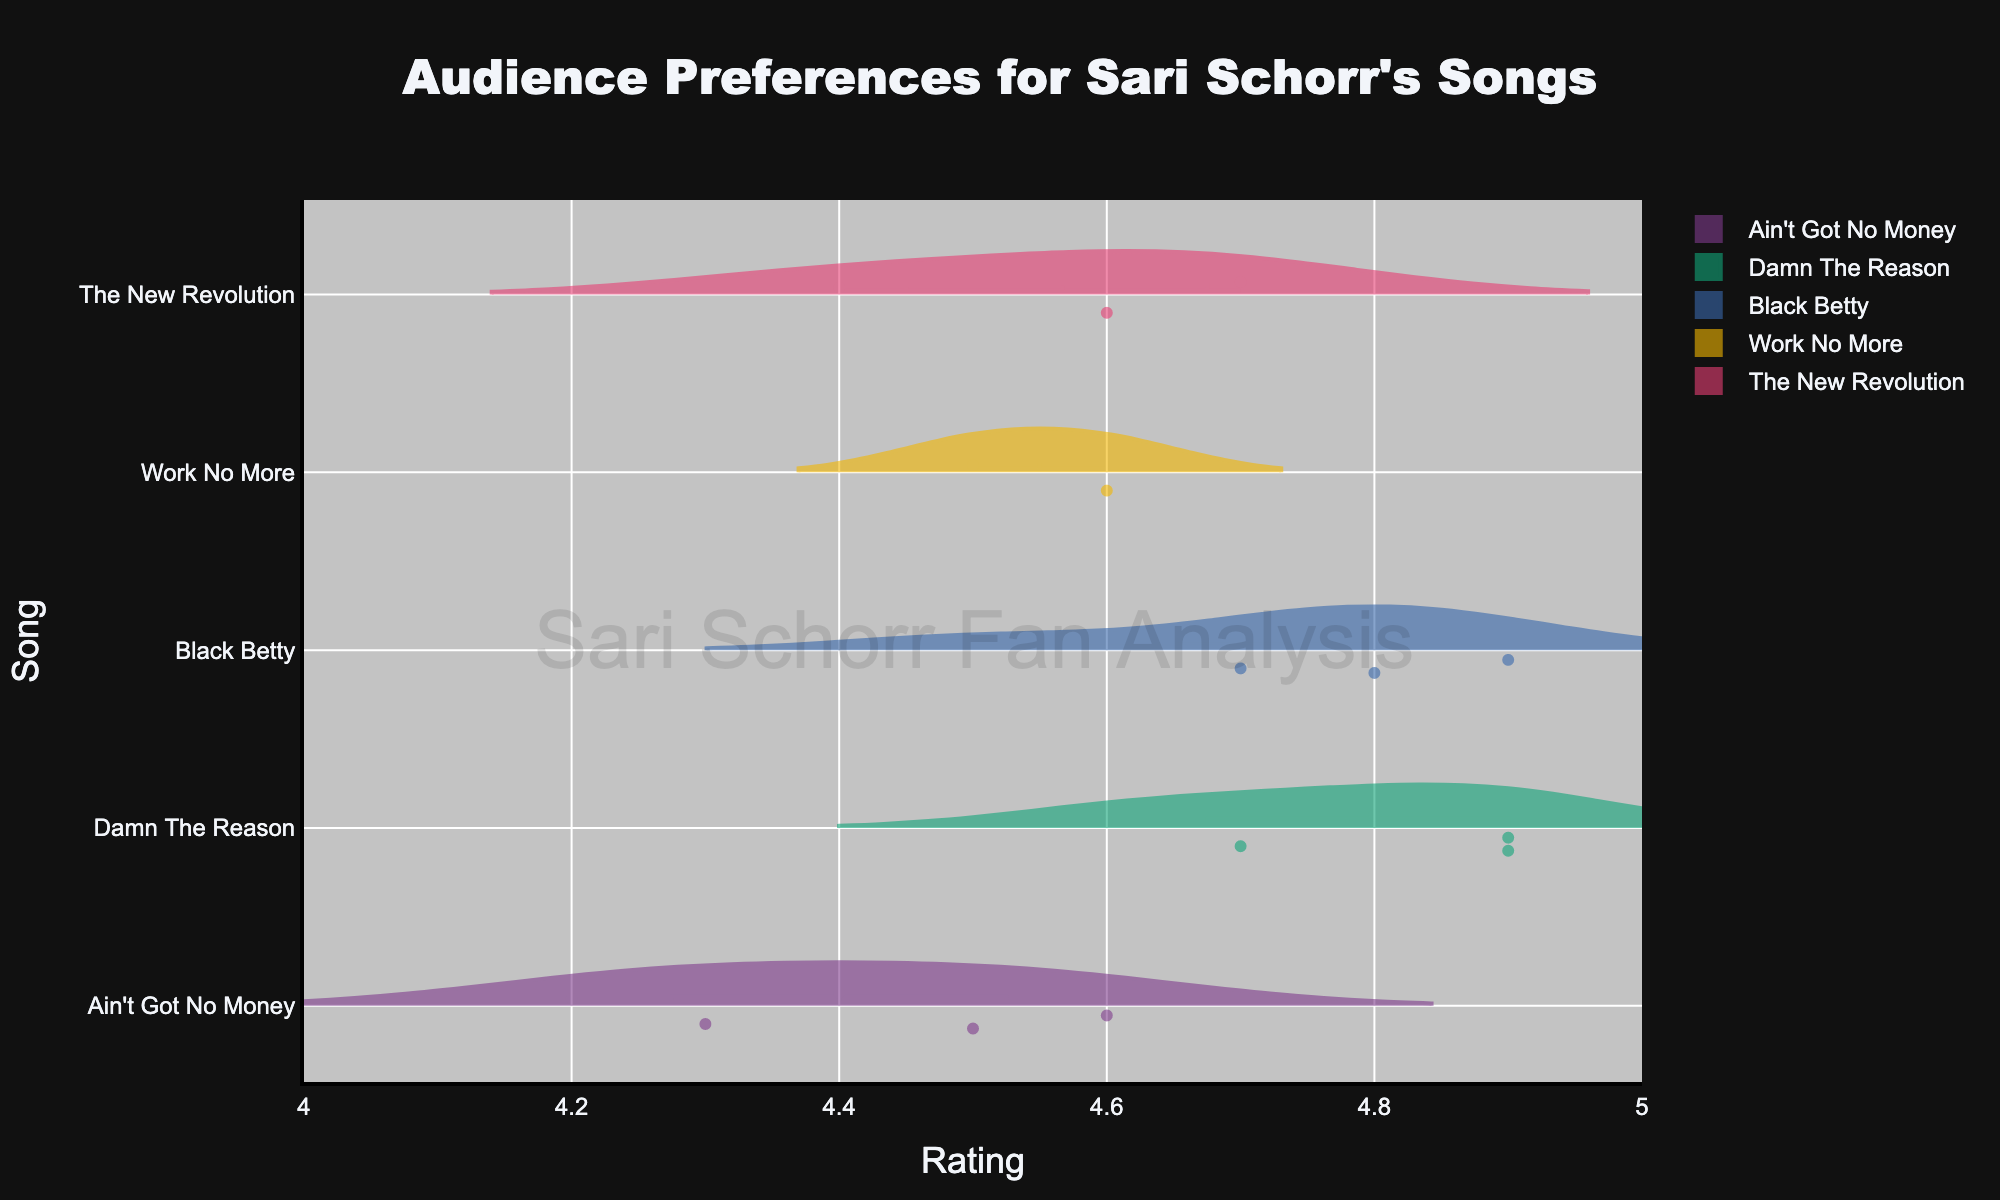What's the overall title of the figure? The overall title is clearly displayed at the top of the figure, using a font size of 24 and the Arial Black font family. It reads "Audience Preferences for Sari Schorr's Songs".
Answer: Audience Preferences for Sari Schorr's Songs What is the color palette used for the individual violin plots? The violin plots use a qualitative bold color palette which assigns distinct and recognizable colors to each song. These colors are designed to help differentiate the individual song ratings visually.
Answer: Bold color palette How is the "mean" value visually indicated in the violin plots? The mean value is marked by a meanline within each violin plot. This helps in identifying the central tendency of the ratings for each song.
Answer: Meanline Which song has the highest median rating? By observing the position of the median line within each violin plot, "Damn The Reason" consistently shows a median line near the top of its rating range, indicating the highest median rating.
Answer: Damn The Reason Compare the rating spreads (width of the violin plots) between "Black Betty" and "Ain't Got No Money". Which has a narrower spread of ratings? The width of each violin plot at any given y position represents the density of the ratings. "Black Betty" shows a more concentrated area, indicating less variability and a narrower spread compared to "Ain't Got No Money", which shows a more spread-out shape.
Answer: Black Betty What's the average rating for "Ain't Got No Money"? There are five ratings for "Ain't Got No Money" shown in the figure: 4.5, 4.2, 4.3, 4.4, and 4.6. To find the average, sum these ratings and divide by the number of ratings. So, (4.5 + 4.2 + 4.3 + 4.4 + 4.6)/5 = 4.4.
Answer: 4.4 Which songs have ratings displayed within the range of 4.8 and above? By examining the x-axis range and the spread of the violin plots, "Damn The Reason" and "Black Betty" have ratings within the range of 4.8 and above, consistently shown above this threshold.
Answer: Damn The Reason, Black Betty Is there any song with consistently low ratings (below 4.2) across all concerts? Observing the figure, no song consistently has ratings below 4.2. All songs display ratings at least within or above this range within their respective violin plot areas.
Answer: No How are the individual ratings shown within each violin plot? Individual ratings are displayed as points within each violin plot, scattered with some jitter and positioned near the main density area to aid in visualizing the distribution.
Answer: As individual points 